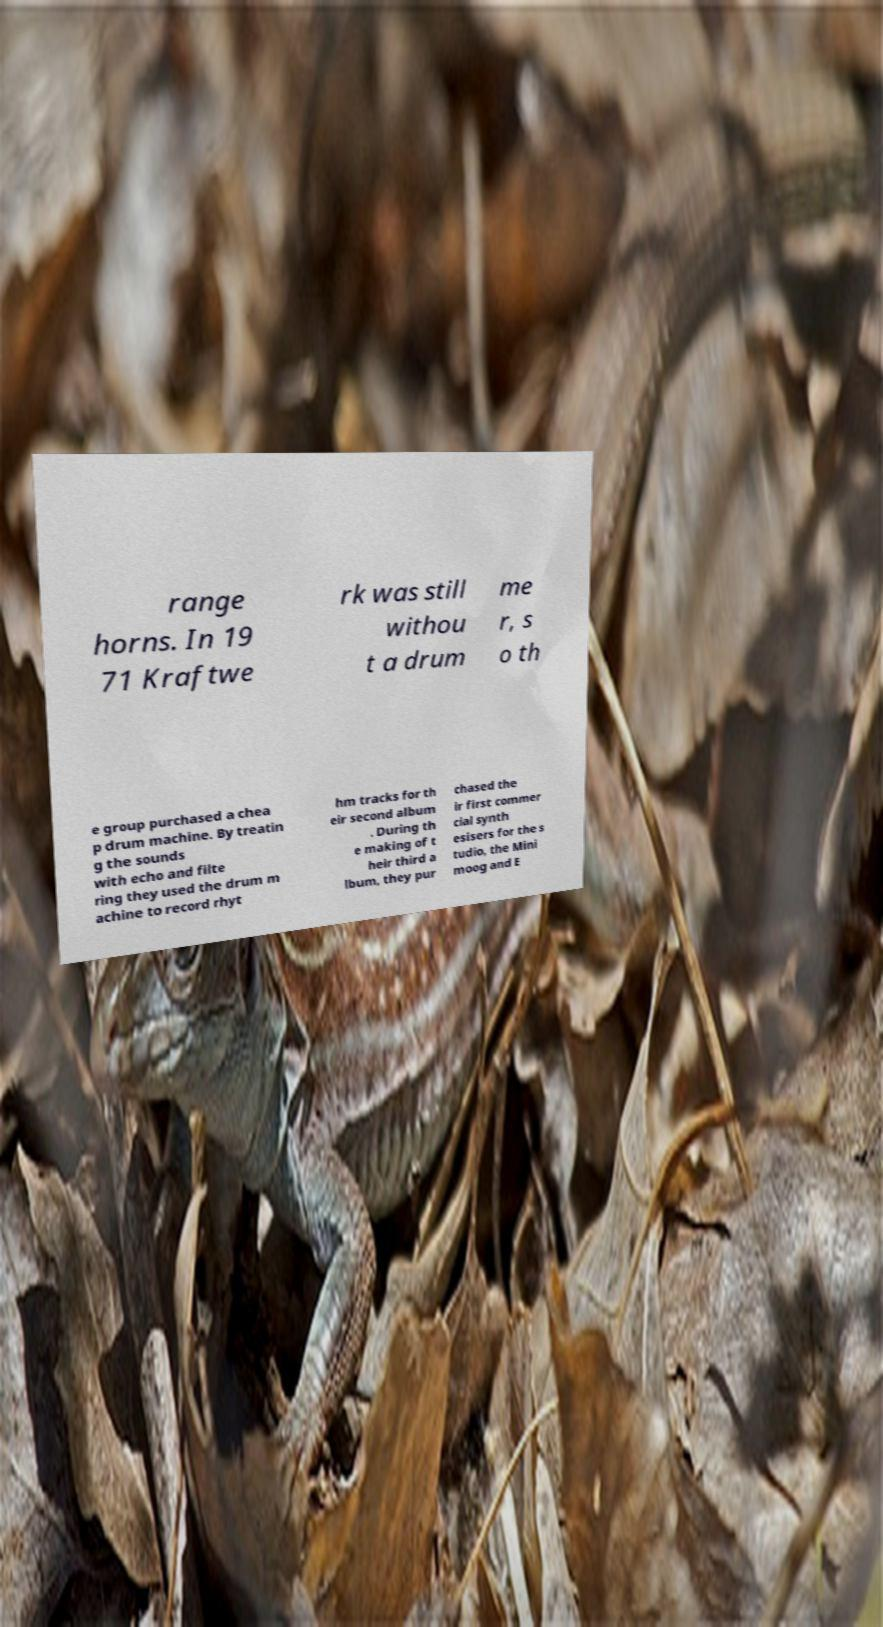What messages or text are displayed in this image? I need them in a readable, typed format. range horns. In 19 71 Kraftwe rk was still withou t a drum me r, s o th e group purchased a chea p drum machine. By treatin g the sounds with echo and filte ring they used the drum m achine to record rhyt hm tracks for th eir second album . During th e making of t heir third a lbum, they pur chased the ir first commer cial synth esisers for the s tudio, the Mini moog and E 